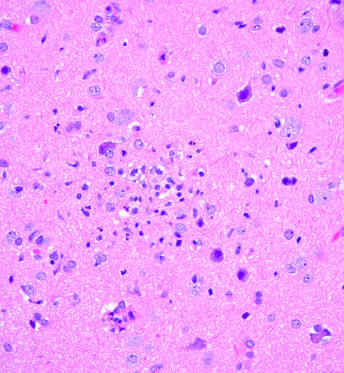what form a poorly defined nodule?
Answer the question using a single word or phrase. Collection of microglial cells 